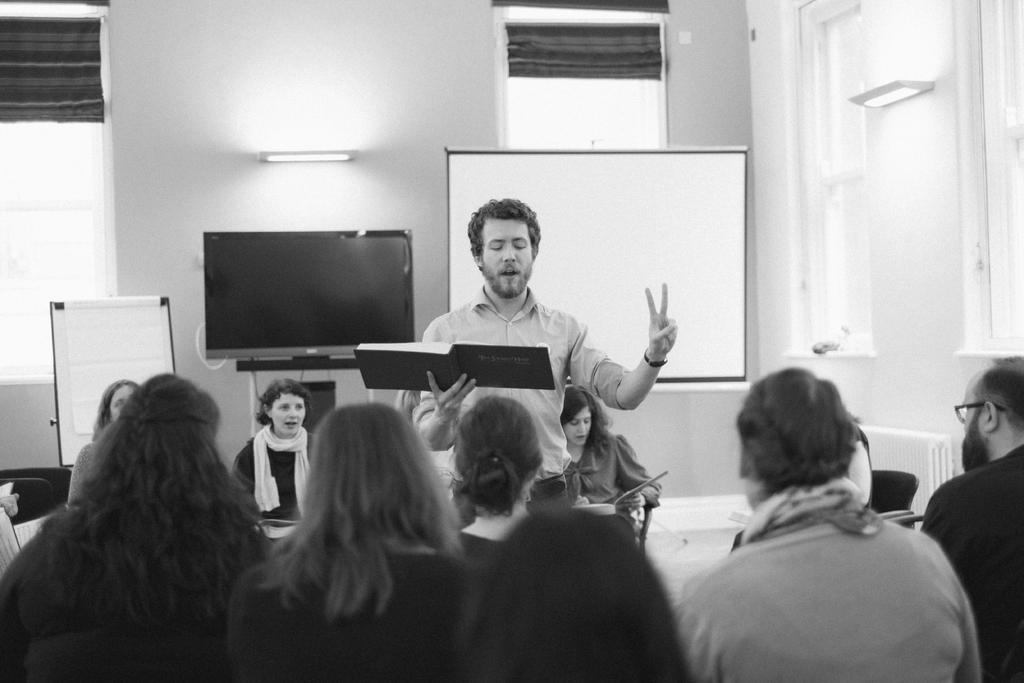How would you summarize this image in a sentence or two? This is a black and white image. The picture is taken inside a room. In the foreground of the picture there are people sitting. In the center of the picture there is a man standing, holding a book. In the background there are people sitting in chairs, behind them there are television, screen and board. At the top there are windows, window blinds, wall and a light. On the right there are windows. 